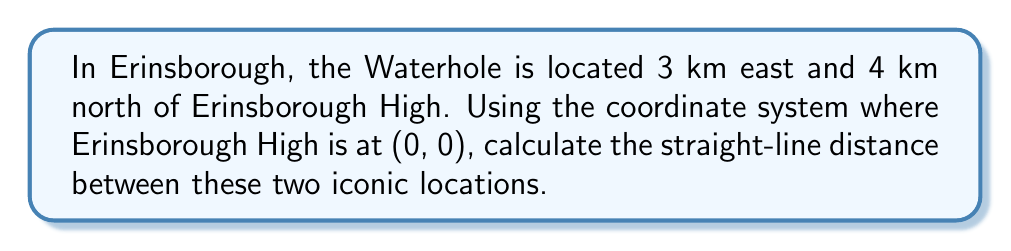Help me with this question. Let's approach this step-by-step:

1) We can treat this as a right-angled triangle problem, where:
   - Erinsborough High is at the origin (0, 0)
   - The Waterhole is at the point (3, 4)

2) We can use the Pythagorean theorem to calculate the distance:

   $$d = \sqrt{x^2 + y^2}$$

   Where $d$ is the distance, $x$ is the horizontal distance, and $y$ is the vertical distance.

3) Substituting our values:

   $$d = \sqrt{3^2 + 4^2}$$

4) Simplify:

   $$d = \sqrt{9 + 16}$$
   $$d = \sqrt{25}$$

5) Solve:

   $$d = 5$$

Therefore, the straight-line distance between Erinsborough High and the Waterhole is 5 km.

[asy]
unitsize(1cm);
draw((0,0)--(3,0)--(3,4)--(0,0),black);
label("Erinsborough High (0,0)", (0,0), SW);
label("The Waterhole (3,4)", (3,4), NE);
label("3 km", (1.5,0), S);
label("4 km", (3,2), E);
label("5 km", (1.5,2), NW);
dot((0,0));
dot((3,4));
[/asy]
Answer: 5 km 